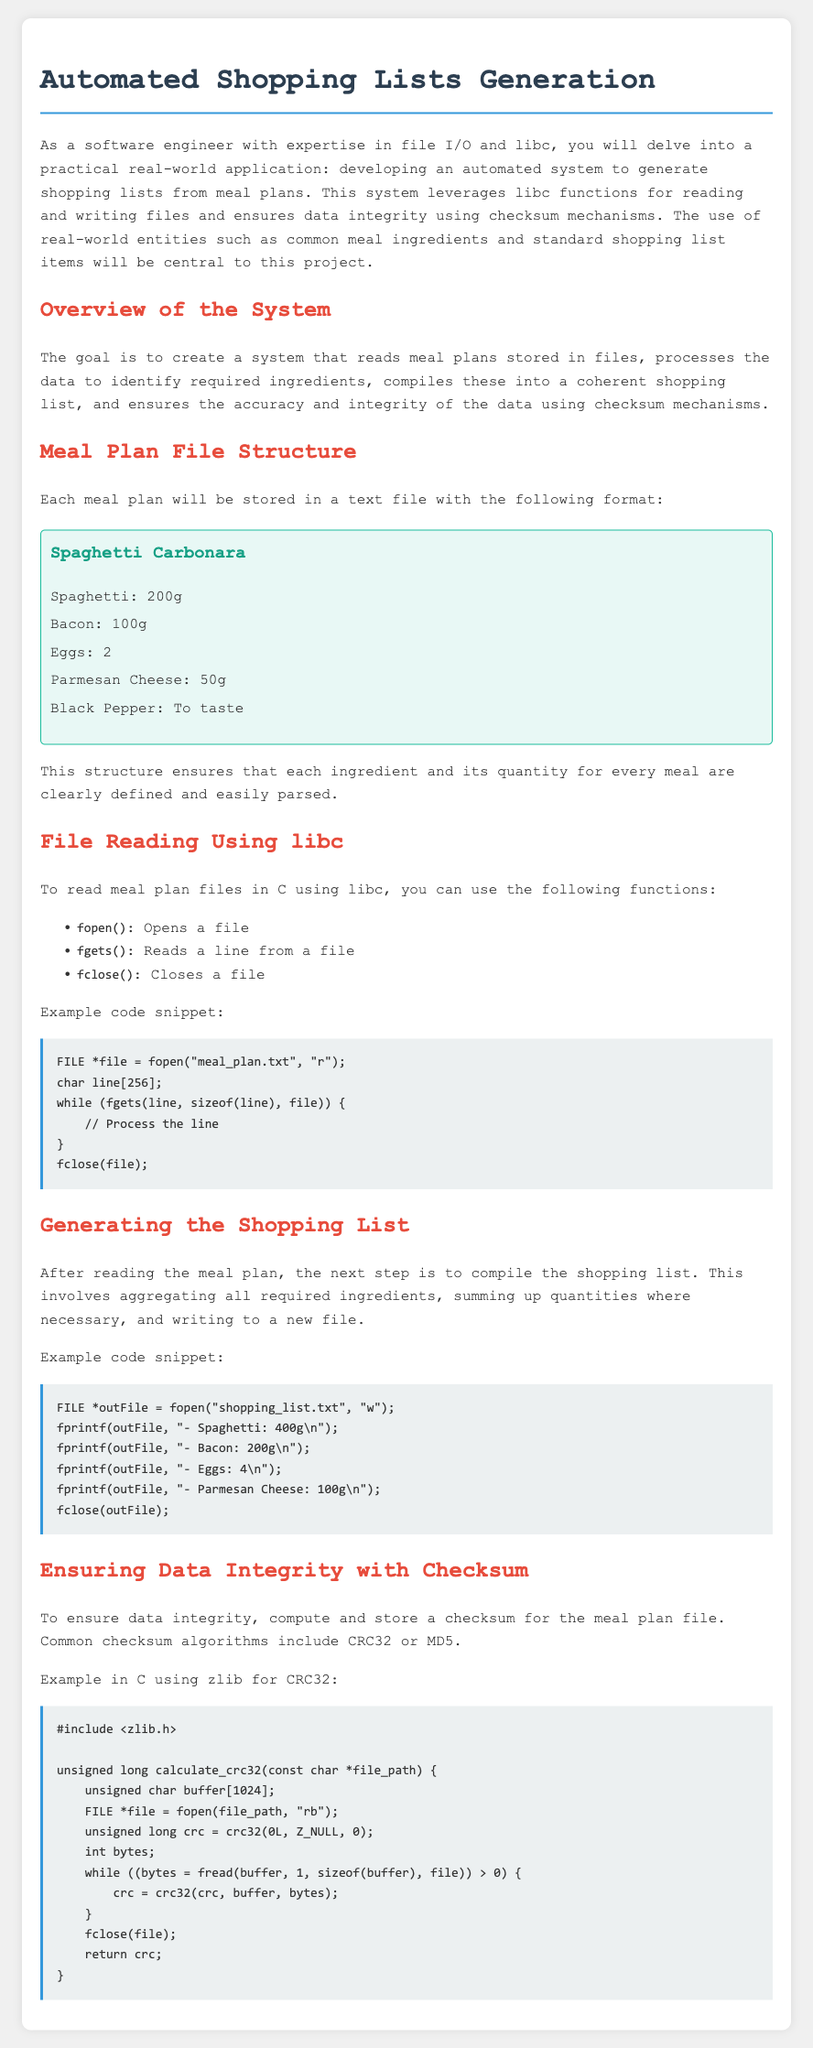What is the title of the document? The title of the document is found in the HTML `<title>` tag, which is "Automated Shopping Lists Generation."
Answer: Automated Shopping Lists Generation What is the purpose of the system? The purpose of the system is outlined in the overview section as creating a system that generates shopping lists from meal plans.
Answer: Generate shopping lists Which meal is included in the meal plan example? The meal plan provides a specific example titled "Spaghetti Carbonara."
Answer: Spaghetti Carbonara What function is used to open a file in C? The function used to open a file is listed under file reading using libc, which is `fopen()`.
Answer: fopen What checksum algorithm is mentioned in the document? The document mentions common checksum algorithms including CRC32 and MD5, indicating options for ensuring data integrity.
Answer: CRC32, MD5 How many eggs are required for the Spaghetti Carbonara? The requirements for Spaghetti Carbonara specify that 2 eggs are needed.
Answer: 2 What is the minimum number of ingredients listed for the meal plan? The meal plan for Spaghetti Carbonara consists of 5 ingredients.
Answer: 5 What is the output file name for the shopping list? The example code snippet states that the output file for the shopping list is "shopping_list.txt."
Answer: shopping_list.txt Which library is used for CRC32 in the example? The document specifies that the zlib library is used for CRC32 calculations in the example provided.
Answer: zlib 